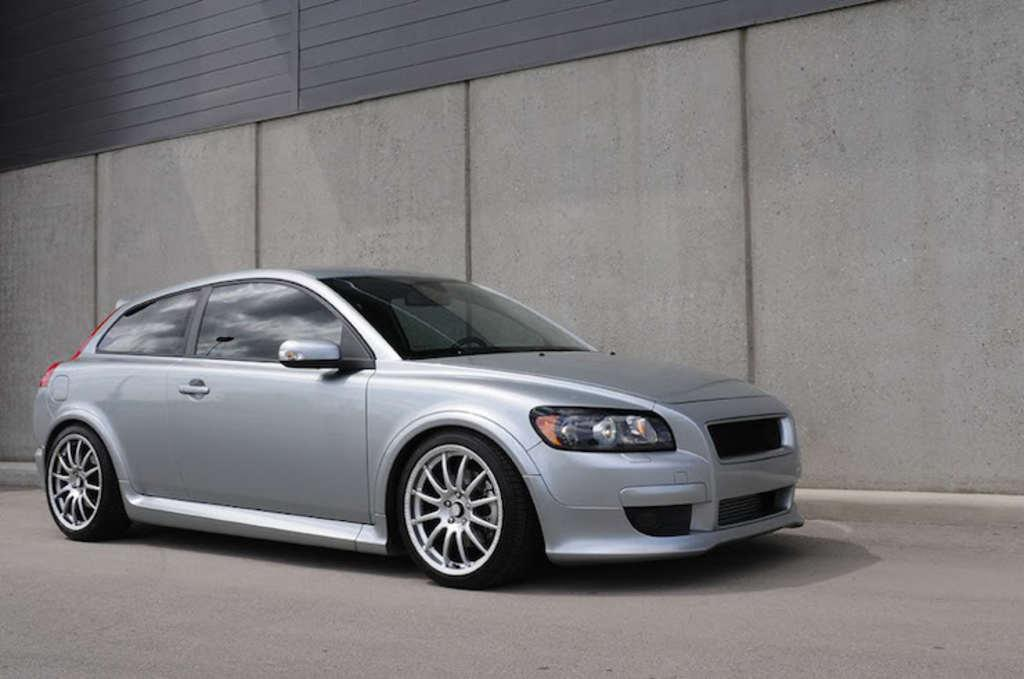What is the main subject of the image? The main subject of the image is a car. Can you describe the car's appearance? The car is silver in color. What else can be seen in the image besides the car? There is a wall in the image. How many boys are playing near the car in the image? There are no boys present in the image; it only features a car and a wall. What role does the government play in the image? The government is not mentioned or depicted in the image; it only shows a car and a wall. 